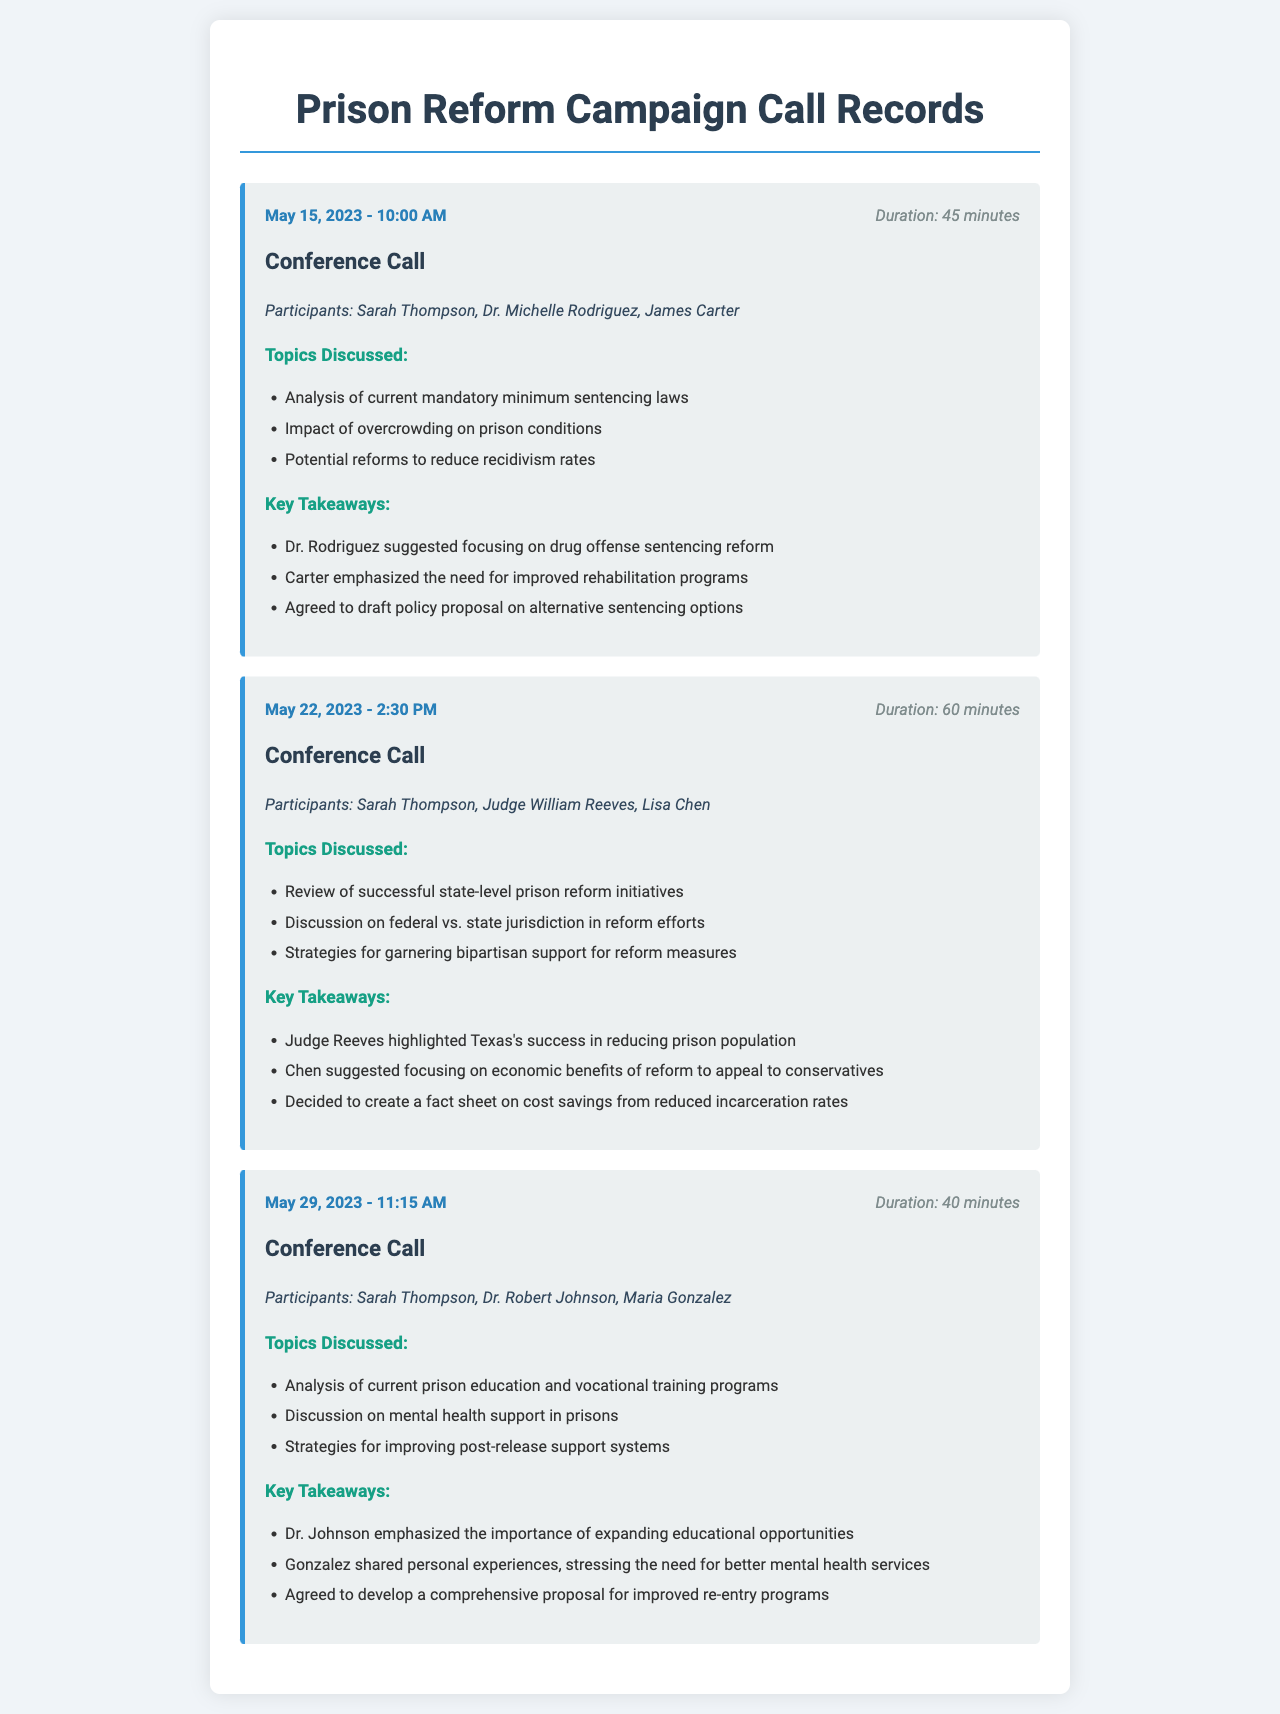What date was the first conference call held? The first call took place on May 15, 2023.
Answer: May 15, 2023 Who were the participants in the second call? The participants for the second call were Sarah Thompson, Judge William Reeves, and Lisa Chen.
Answer: Sarah Thompson, Judge William Reeves, Lisa Chen What was the duration of the third conference call? The duration of the third call was 40 minutes.
Answer: 40 minutes Which state's success in prison reform was highlighted? Judge Reeves highlighted Texas's success in reducing the prison population.
Answer: Texas What key takeaway was agreed upon in the first call? The group agreed to draft a policy proposal on alternative sentencing options.
Answer: Draft policy proposal on alternative sentencing options How many participants were in the first call? There were three participants in the first call.
Answer: Three What topic was discussed regarding prison education in the third call? The topic discussed was the analysis of current prison education and vocational training programs.
Answer: Analysis of current prison education and vocational training programs What was one of the strategies discussed in the second call? One of the strategies discussed was garnering bipartisan support for reform measures.
Answer: Garnering bipartisan support for reform measures 